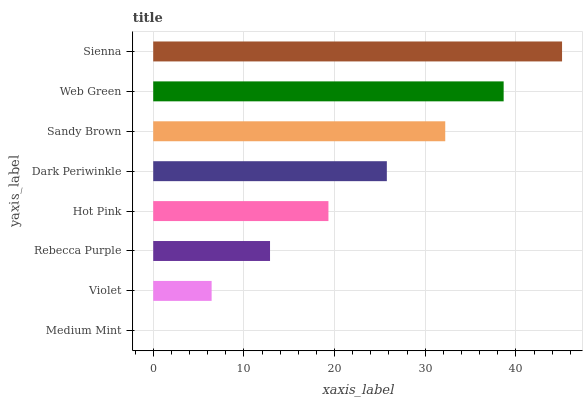Is Medium Mint the minimum?
Answer yes or no. Yes. Is Sienna the maximum?
Answer yes or no. Yes. Is Violet the minimum?
Answer yes or no. No. Is Violet the maximum?
Answer yes or no. No. Is Violet greater than Medium Mint?
Answer yes or no. Yes. Is Medium Mint less than Violet?
Answer yes or no. Yes. Is Medium Mint greater than Violet?
Answer yes or no. No. Is Violet less than Medium Mint?
Answer yes or no. No. Is Dark Periwinkle the high median?
Answer yes or no. Yes. Is Hot Pink the low median?
Answer yes or no. Yes. Is Sandy Brown the high median?
Answer yes or no. No. Is Medium Mint the low median?
Answer yes or no. No. 